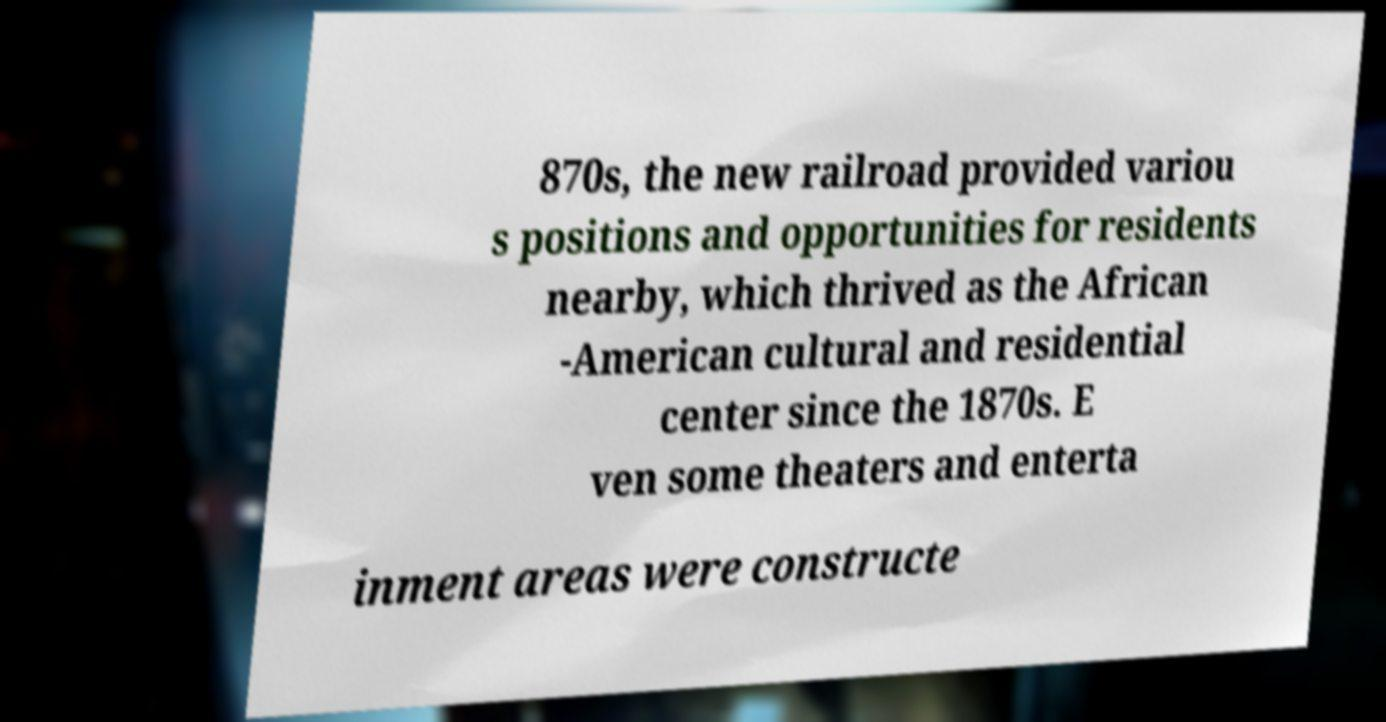What messages or text are displayed in this image? I need them in a readable, typed format. 870s, the new railroad provided variou s positions and opportunities for residents nearby, which thrived as the African -American cultural and residential center since the 1870s. E ven some theaters and enterta inment areas were constructe 